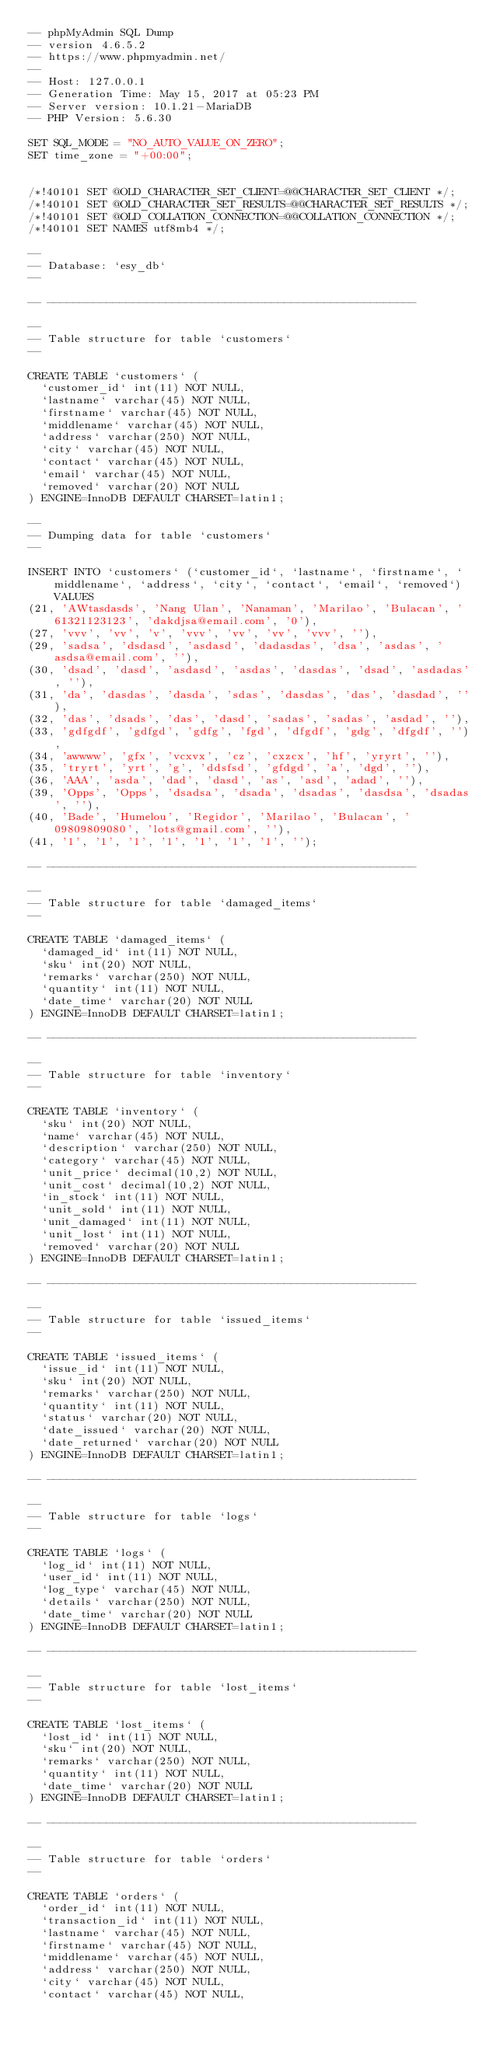<code> <loc_0><loc_0><loc_500><loc_500><_SQL_>-- phpMyAdmin SQL Dump
-- version 4.6.5.2
-- https://www.phpmyadmin.net/
--
-- Host: 127.0.0.1
-- Generation Time: May 15, 2017 at 05:23 PM
-- Server version: 10.1.21-MariaDB
-- PHP Version: 5.6.30

SET SQL_MODE = "NO_AUTO_VALUE_ON_ZERO";
SET time_zone = "+00:00";


/*!40101 SET @OLD_CHARACTER_SET_CLIENT=@@CHARACTER_SET_CLIENT */;
/*!40101 SET @OLD_CHARACTER_SET_RESULTS=@@CHARACTER_SET_RESULTS */;
/*!40101 SET @OLD_COLLATION_CONNECTION=@@COLLATION_CONNECTION */;
/*!40101 SET NAMES utf8mb4 */;

--
-- Database: `esy_db`
--

-- --------------------------------------------------------

--
-- Table structure for table `customers`
--

CREATE TABLE `customers` (
  `customer_id` int(11) NOT NULL,
  `lastname` varchar(45) NOT NULL,
  `firstname` varchar(45) NOT NULL,
  `middlename` varchar(45) NOT NULL,
  `address` varchar(250) NOT NULL,
  `city` varchar(45) NOT NULL,
  `contact` varchar(45) NOT NULL,
  `email` varchar(45) NOT NULL,
  `removed` varchar(20) NOT NULL
) ENGINE=InnoDB DEFAULT CHARSET=latin1;

--
-- Dumping data for table `customers`
--

INSERT INTO `customers` (`customer_id`, `lastname`, `firstname`, `middlename`, `address`, `city`, `contact`, `email`, `removed`) VALUES
(21, 'AWtasdasds', 'Nang Ulan', 'Nanaman', 'Marilao', 'Bulacan', '61321123123', 'dakdjsa@email.com', '0'),
(27, 'vvv', 'vv', 'v', 'vvv', 'vv', 'vv', 'vvv', ''),
(29, 'sadsa', 'dsdasd', 'asdasd', 'dadasdas', 'dsa', 'asdas', 'asdsa@email.com', ''),
(30, 'dsad', 'dasd', 'asdasd', 'asdas', 'dasdas', 'dsad', 'asdadas', ''),
(31, 'da', 'dasdas', 'dasda', 'sdas', 'dasdas', 'das', 'dasdad', ''),
(32, 'das', 'dsads', 'das', 'dasd', 'sadas', 'sadas', 'asdad', ''),
(33, 'gdfgdf', 'gdfgd', 'gdfg', 'fgd', 'dfgdf', 'gdg', 'dfgdf', ''),
(34, 'awwww', 'gfx', 'vcxvx', 'cz', 'cxzcx', 'hf', 'yryrt', ''),
(35, 'tryrt', 'yrt', 'g', 'ddsfsd', 'gfdgd', 'a', 'dgd', ''),
(36, 'AAA', 'asda', 'dad', 'dasd', 'as', 'asd', 'adad', ''),
(39, 'Opps', 'Opps', 'dsadsa', 'dsada', 'dsadas', 'dasdsa', 'dsadas', ''),
(40, 'Bade', 'Humelou', 'Regidor', 'Marilao', 'Bulacan', '09809809080', 'lots@gmail.com', ''),
(41, '1', '1', '1', '1', '1', '1', '1', '');

-- --------------------------------------------------------

--
-- Table structure for table `damaged_items`
--

CREATE TABLE `damaged_items` (
  `damaged_id` int(11) NOT NULL,
  `sku` int(20) NOT NULL,
  `remarks` varchar(250) NOT NULL,
  `quantity` int(11) NOT NULL,
  `date_time` varchar(20) NOT NULL
) ENGINE=InnoDB DEFAULT CHARSET=latin1;

-- --------------------------------------------------------

--
-- Table structure for table `inventory`
--

CREATE TABLE `inventory` (
  `sku` int(20) NOT NULL,
  `name` varchar(45) NOT NULL,
  `description` varchar(250) NOT NULL,
  `category` varchar(45) NOT NULL,
  `unit_price` decimal(10,2) NOT NULL,
  `unit_cost` decimal(10,2) NOT NULL,
  `in_stock` int(11) NOT NULL,
  `unit_sold` int(11) NOT NULL,
  `unit_damaged` int(11) NOT NULL,
  `unit_lost` int(11) NOT NULL,
  `removed` varchar(20) NOT NULL
) ENGINE=InnoDB DEFAULT CHARSET=latin1;

-- --------------------------------------------------------

--
-- Table structure for table `issued_items`
--

CREATE TABLE `issued_items` (
  `issue_id` int(11) NOT NULL,
  `sku` int(20) NOT NULL,
  `remarks` varchar(250) NOT NULL,
  `quantity` int(11) NOT NULL,
  `status` varchar(20) NOT NULL,
  `date_issued` varchar(20) NOT NULL,
  `date_returned` varchar(20) NOT NULL
) ENGINE=InnoDB DEFAULT CHARSET=latin1;

-- --------------------------------------------------------

--
-- Table structure for table `logs`
--

CREATE TABLE `logs` (
  `log_id` int(11) NOT NULL,
  `user_id` int(11) NOT NULL,
  `log_type` varchar(45) NOT NULL,
  `details` varchar(250) NOT NULL,
  `date_time` varchar(20) NOT NULL
) ENGINE=InnoDB DEFAULT CHARSET=latin1;

-- --------------------------------------------------------

--
-- Table structure for table `lost_items`
--

CREATE TABLE `lost_items` (
  `lost_id` int(11) NOT NULL,
  `sku` int(20) NOT NULL,
  `remarks` varchar(250) NOT NULL,
  `quantity` int(11) NOT NULL,
  `date_time` varchar(20) NOT NULL
) ENGINE=InnoDB DEFAULT CHARSET=latin1;

-- --------------------------------------------------------

--
-- Table structure for table `orders`
--

CREATE TABLE `orders` (
  `order_id` int(11) NOT NULL,
  `transaction_id` int(11) NOT NULL,
  `lastname` varchar(45) NOT NULL,
  `firstname` varchar(45) NOT NULL,
  `middlename` varchar(45) NOT NULL,
  `address` varchar(250) NOT NULL,
  `city` varchar(45) NOT NULL,
  `contact` varchar(45) NOT NULL,</code> 